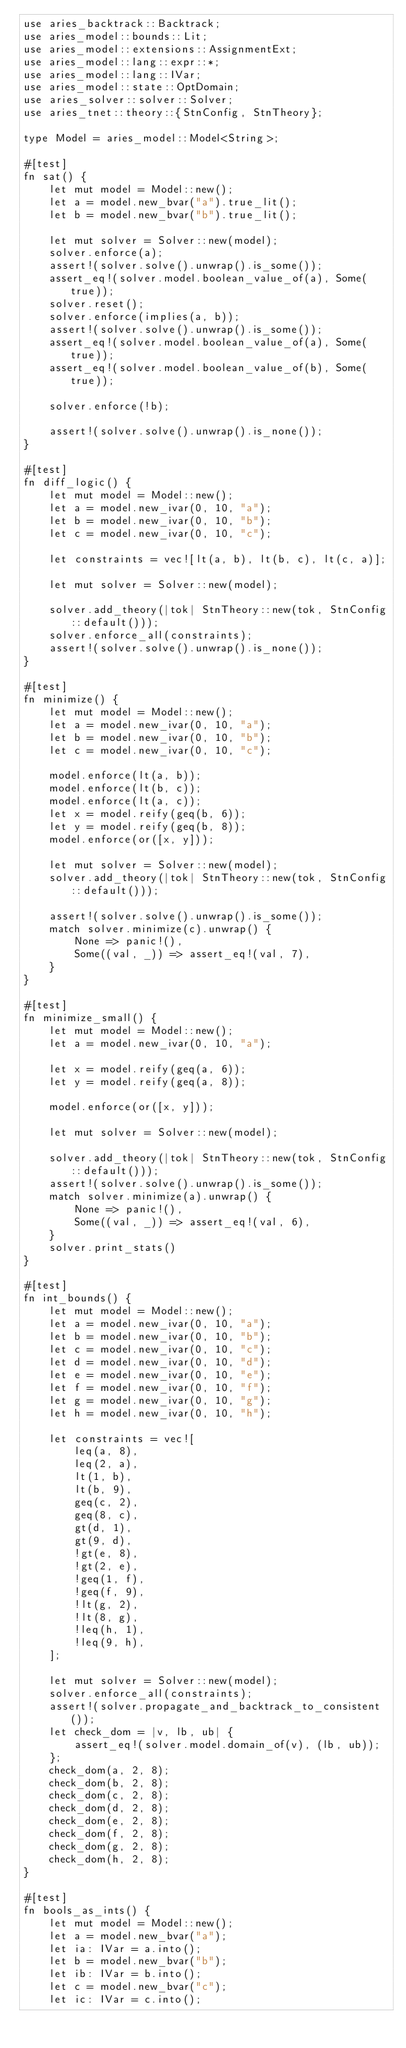Convert code to text. <code><loc_0><loc_0><loc_500><loc_500><_Rust_>use aries_backtrack::Backtrack;
use aries_model::bounds::Lit;
use aries_model::extensions::AssignmentExt;
use aries_model::lang::expr::*;
use aries_model::lang::IVar;
use aries_model::state::OptDomain;
use aries_solver::solver::Solver;
use aries_tnet::theory::{StnConfig, StnTheory};

type Model = aries_model::Model<String>;

#[test]
fn sat() {
    let mut model = Model::new();
    let a = model.new_bvar("a").true_lit();
    let b = model.new_bvar("b").true_lit();

    let mut solver = Solver::new(model);
    solver.enforce(a);
    assert!(solver.solve().unwrap().is_some());
    assert_eq!(solver.model.boolean_value_of(a), Some(true));
    solver.reset();
    solver.enforce(implies(a, b));
    assert!(solver.solve().unwrap().is_some());
    assert_eq!(solver.model.boolean_value_of(a), Some(true));
    assert_eq!(solver.model.boolean_value_of(b), Some(true));

    solver.enforce(!b);

    assert!(solver.solve().unwrap().is_none());
}

#[test]
fn diff_logic() {
    let mut model = Model::new();
    let a = model.new_ivar(0, 10, "a");
    let b = model.new_ivar(0, 10, "b");
    let c = model.new_ivar(0, 10, "c");

    let constraints = vec![lt(a, b), lt(b, c), lt(c, a)];

    let mut solver = Solver::new(model);

    solver.add_theory(|tok| StnTheory::new(tok, StnConfig::default()));
    solver.enforce_all(constraints);
    assert!(solver.solve().unwrap().is_none());
}

#[test]
fn minimize() {
    let mut model = Model::new();
    let a = model.new_ivar(0, 10, "a");
    let b = model.new_ivar(0, 10, "b");
    let c = model.new_ivar(0, 10, "c");

    model.enforce(lt(a, b));
    model.enforce(lt(b, c));
    model.enforce(lt(a, c));
    let x = model.reify(geq(b, 6));
    let y = model.reify(geq(b, 8));
    model.enforce(or([x, y]));

    let mut solver = Solver::new(model);
    solver.add_theory(|tok| StnTheory::new(tok, StnConfig::default()));

    assert!(solver.solve().unwrap().is_some());
    match solver.minimize(c).unwrap() {
        None => panic!(),
        Some((val, _)) => assert_eq!(val, 7),
    }
}

#[test]
fn minimize_small() {
    let mut model = Model::new();
    let a = model.new_ivar(0, 10, "a");

    let x = model.reify(geq(a, 6));
    let y = model.reify(geq(a, 8));

    model.enforce(or([x, y]));

    let mut solver = Solver::new(model);

    solver.add_theory(|tok| StnTheory::new(tok, StnConfig::default()));
    assert!(solver.solve().unwrap().is_some());
    match solver.minimize(a).unwrap() {
        None => panic!(),
        Some((val, _)) => assert_eq!(val, 6),
    }
    solver.print_stats()
}

#[test]
fn int_bounds() {
    let mut model = Model::new();
    let a = model.new_ivar(0, 10, "a");
    let b = model.new_ivar(0, 10, "b");
    let c = model.new_ivar(0, 10, "c");
    let d = model.new_ivar(0, 10, "d");
    let e = model.new_ivar(0, 10, "e");
    let f = model.new_ivar(0, 10, "f");
    let g = model.new_ivar(0, 10, "g");
    let h = model.new_ivar(0, 10, "h");

    let constraints = vec![
        leq(a, 8),
        leq(2, a),
        lt(1, b),
        lt(b, 9),
        geq(c, 2),
        geq(8, c),
        gt(d, 1),
        gt(9, d),
        !gt(e, 8),
        !gt(2, e),
        !geq(1, f),
        !geq(f, 9),
        !lt(g, 2),
        !lt(8, g),
        !leq(h, 1),
        !leq(9, h),
    ];

    let mut solver = Solver::new(model);
    solver.enforce_all(constraints);
    assert!(solver.propagate_and_backtrack_to_consistent());
    let check_dom = |v, lb, ub| {
        assert_eq!(solver.model.domain_of(v), (lb, ub));
    };
    check_dom(a, 2, 8);
    check_dom(b, 2, 8);
    check_dom(c, 2, 8);
    check_dom(d, 2, 8);
    check_dom(e, 2, 8);
    check_dom(f, 2, 8);
    check_dom(g, 2, 8);
    check_dom(h, 2, 8);
}

#[test]
fn bools_as_ints() {
    let mut model = Model::new();
    let a = model.new_bvar("a");
    let ia: IVar = a.into();
    let b = model.new_bvar("b");
    let ib: IVar = b.into();
    let c = model.new_bvar("c");
    let ic: IVar = c.into();</code> 